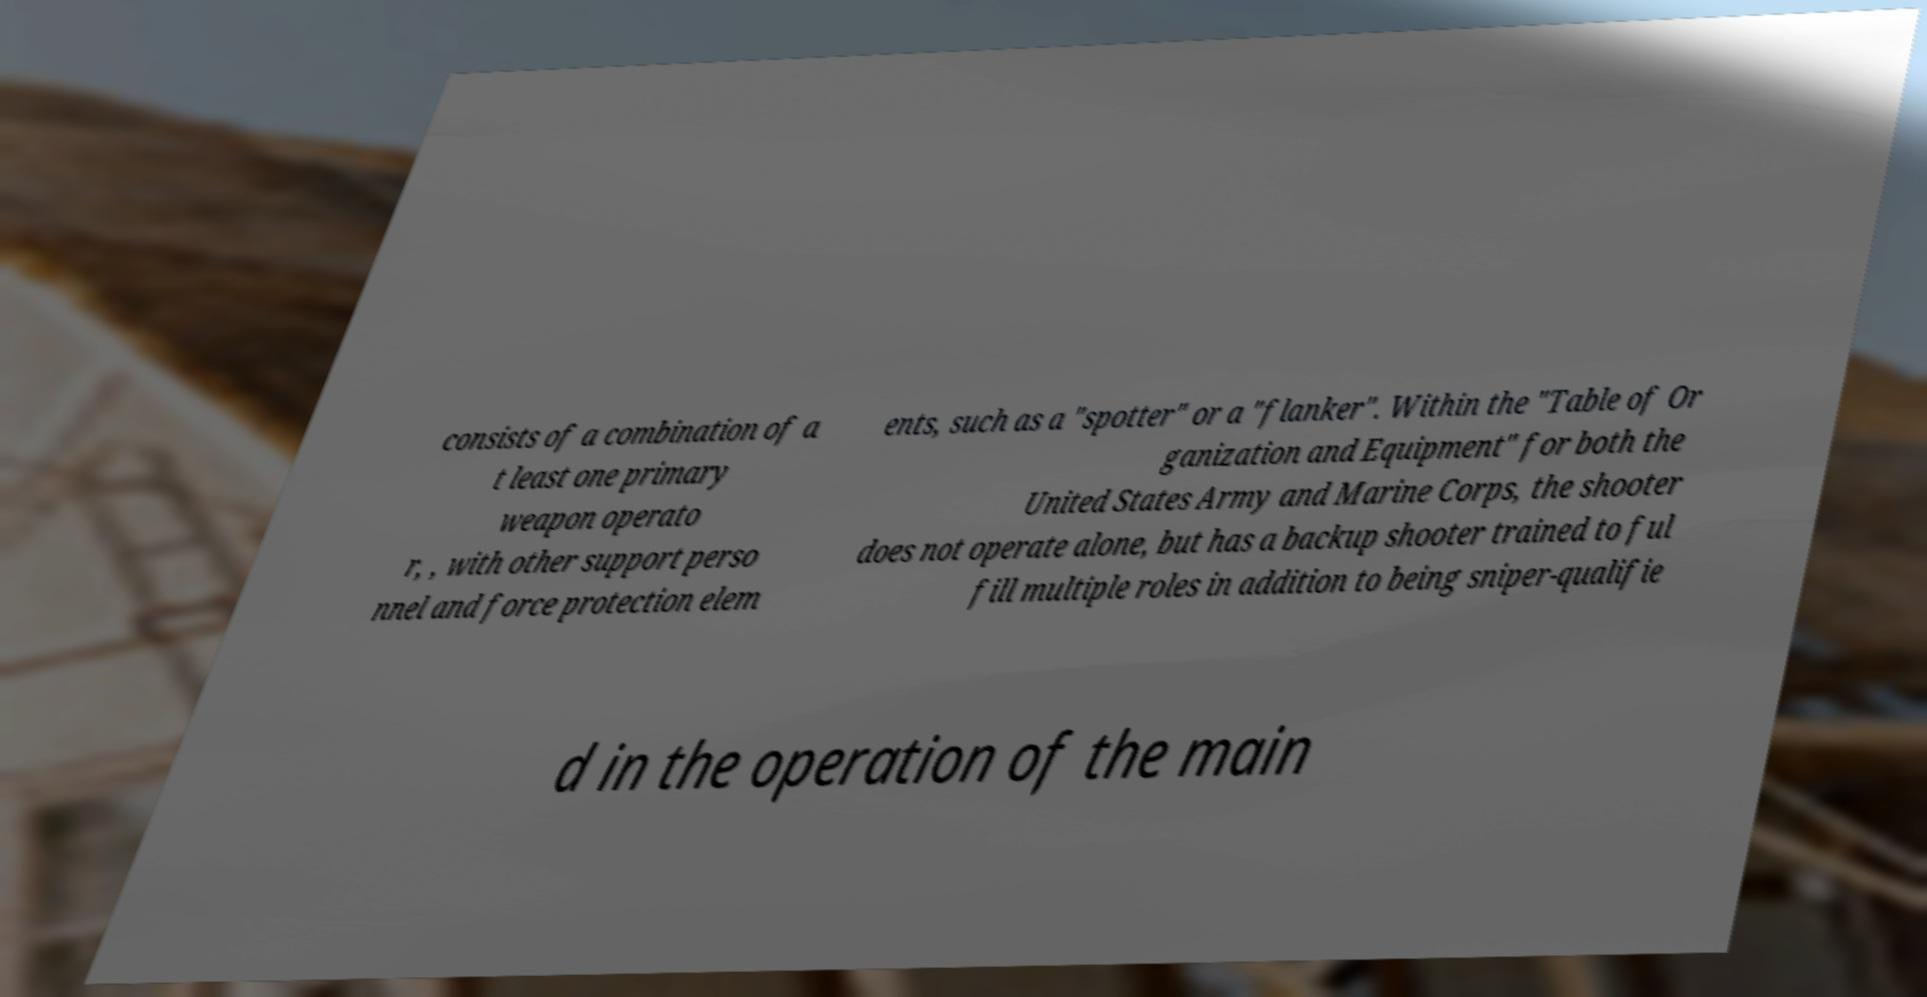Could you assist in decoding the text presented in this image and type it out clearly? consists of a combination of a t least one primary weapon operato r, , with other support perso nnel and force protection elem ents, such as a "spotter" or a "flanker". Within the "Table of Or ganization and Equipment" for both the United States Army and Marine Corps, the shooter does not operate alone, but has a backup shooter trained to ful fill multiple roles in addition to being sniper-qualifie d in the operation of the main 